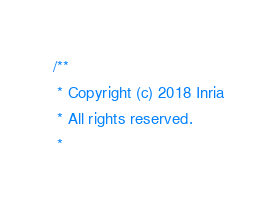Convert code to text. <code><loc_0><loc_0><loc_500><loc_500><_C++_>/**
 * Copyright (c) 2018 Inria
 * All rights reserved.
 *</code> 